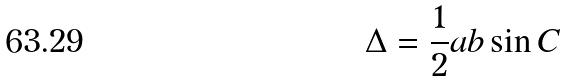<formula> <loc_0><loc_0><loc_500><loc_500>\Delta = \frac { 1 } { 2 } a b \sin C</formula> 